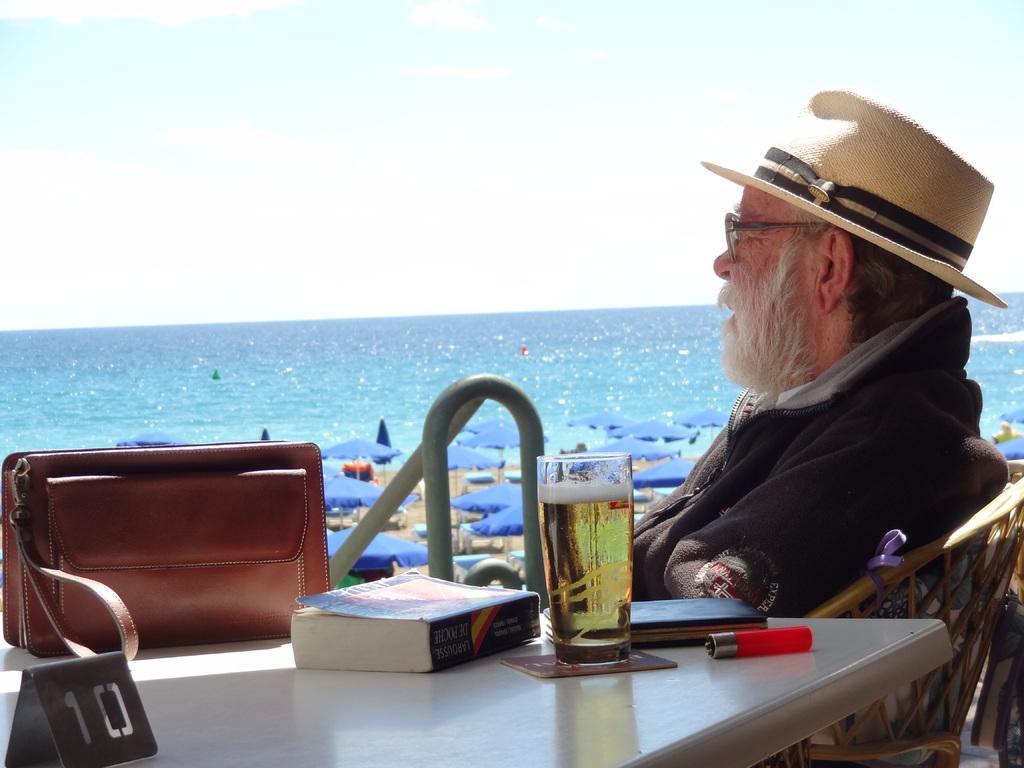Please provide a concise description of this image. In this picture there is a man sitting on chair at a table. He is wearing a brown hoodie, a hat and spectacles. On the table there is a bag, a board, a book, a glass and a lighter. In the image, behind the man there are table umbrellas on the land. In the background there is sky and water. 